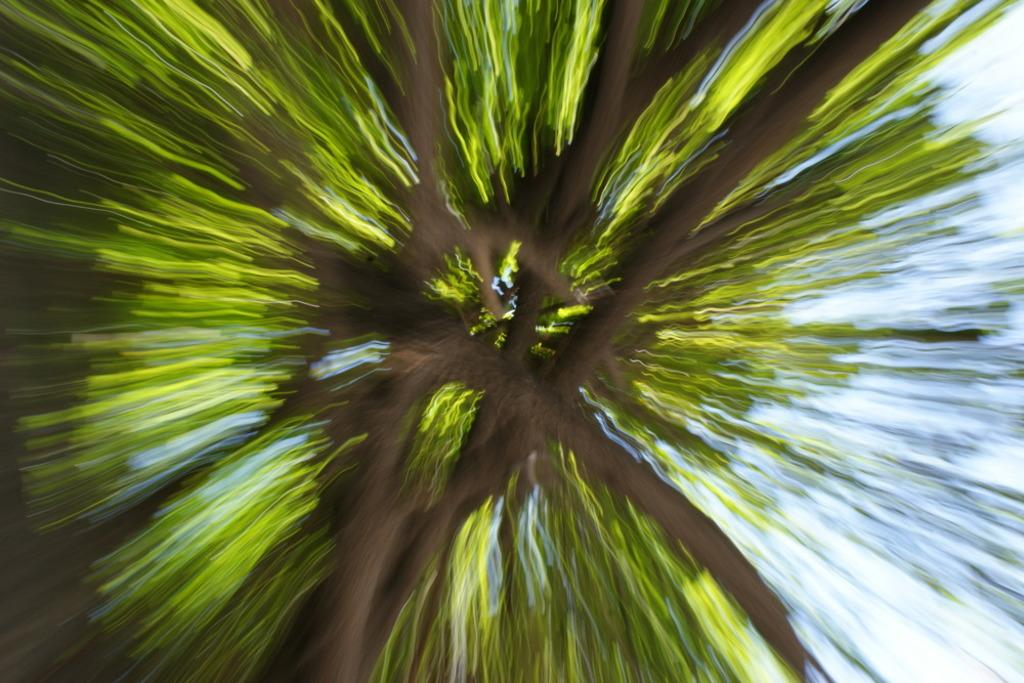What type of natural element can be seen in the image? There is a tree in the image. What part of the environment is visible in the image? The sky is visible in the image. How would you describe the quality of the image? The image appears to be blurred. What type of engine is visible in the image? There is no engine present in the image. How many beams can be seen supporting the tree in the image? There are no beams present in the image; it only features a tree and the sky. 